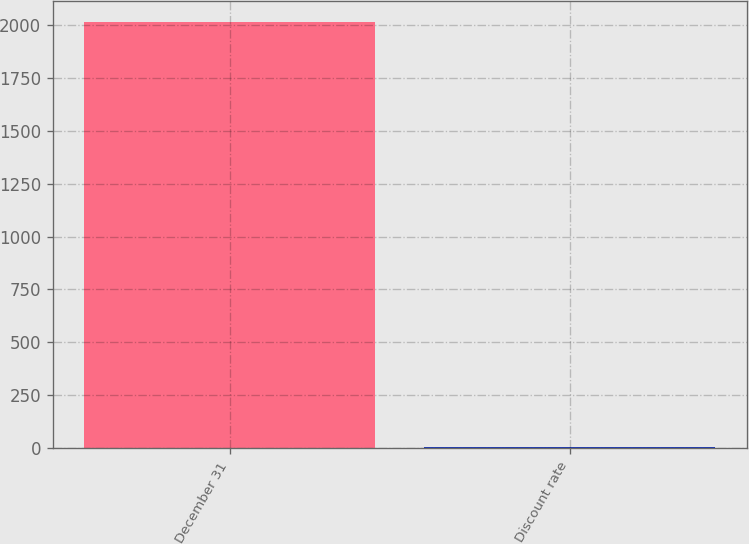Convert chart. <chart><loc_0><loc_0><loc_500><loc_500><bar_chart><fcel>December 31<fcel>Discount rate<nl><fcel>2013<fcel>4.5<nl></chart> 